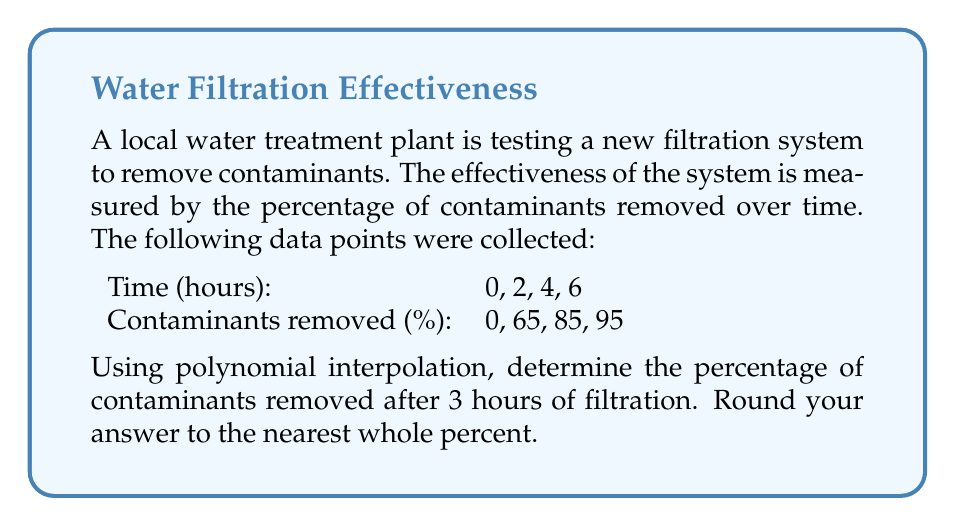Teach me how to tackle this problem. To solve this problem, we'll use Lagrange polynomial interpolation. The Lagrange interpolation polynomial is given by:

$$P(x) = \sum_{i=0}^n y_i \cdot L_i(x)$$

where $L_i(x)$ are the Lagrange basis polynomials:

$$L_i(x) = \prod_{j=0, j \neq i}^n \frac{x - x_j}{x_i - x_j}$$

Given data points:
$(x_0, y_0) = (0, 0)$
$(x_1, y_1) = (2, 65)$
$(x_2, y_2) = (4, 85)$
$(x_3, y_3) = (6, 95)$

We need to find $P(3)$.

Step 1: Calculate the Lagrange basis polynomials for $x = 3$:

$$L_0(3) = \frac{(3-2)(3-4)(3-6)}{(0-2)(0-4)(0-6)} = \frac{1 \cdot (-1) \cdot (-3)}{(-2)(-4)(-6)} = -0.125$$

$$L_1(3) = \frac{(3-0)(3-4)(3-6)}{(2-0)(2-4)(2-6)} = \frac{3 \cdot (-1) \cdot (-3)}{2 \cdot (-2) \cdot (-4)} = 1.125$$

$$L_2(3) = \frac{(3-0)(3-2)(3-6)}{(4-0)(4-2)(4-6)} = \frac{3 \cdot 1 \cdot (-3)}{4 \cdot 2 \cdot (-2)} = 0.5625$$

$$L_3(3) = \frac{(3-0)(3-2)(3-4)}{(6-0)(6-2)(6-4)} = \frac{3 \cdot 1 \cdot (-1)}{6 \cdot 4 \cdot 2} = -0.0625$$

Step 2: Calculate $P(3)$ using the Lagrange interpolation formula:

$$P(3) = 0 \cdot L_0(3) + 65 \cdot L_1(3) + 85 \cdot L_2(3) + 95 \cdot L_3(3)$$

$$P(3) = 0 \cdot (-0.125) + 65 \cdot 1.125 + 85 \cdot 0.5625 + 95 \cdot (-0.0625)$$

$$P(3) = 0 + 73.125 + 47.8125 - 5.9375$$

$$P(3) = 115$$

Step 3: Round to the nearest whole percent:

$$P(3) \approx 115\%$$

However, since the percentage of contaminants removed cannot exceed 100%, we limit our answer to 100%.
Answer: 100% 